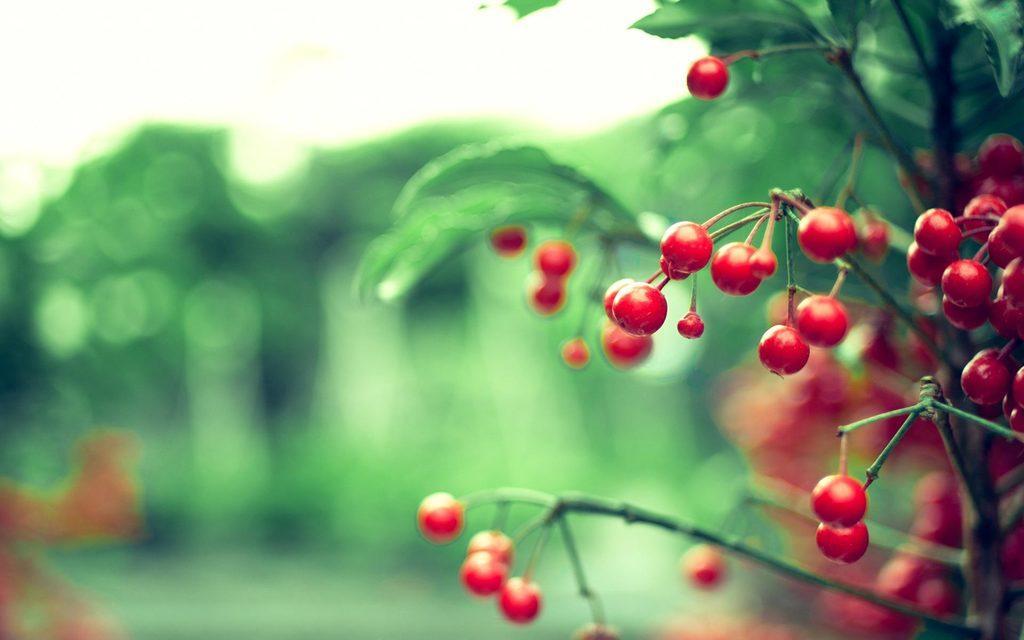Could you give a brief overview of what you see in this image? It is a zoom in picture of red color fruit plant and the background is blurry. 